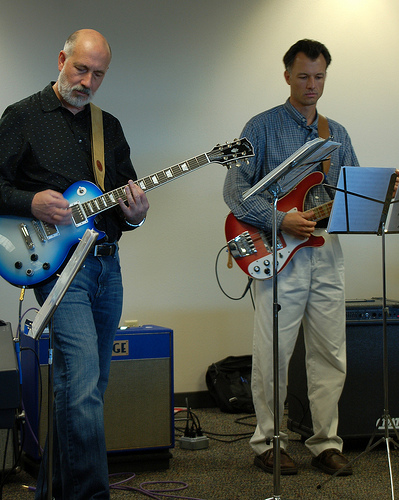<image>
Can you confirm if the music stand is in front of the guitar player? No. The music stand is not in front of the guitar player. The spatial positioning shows a different relationship between these objects. 